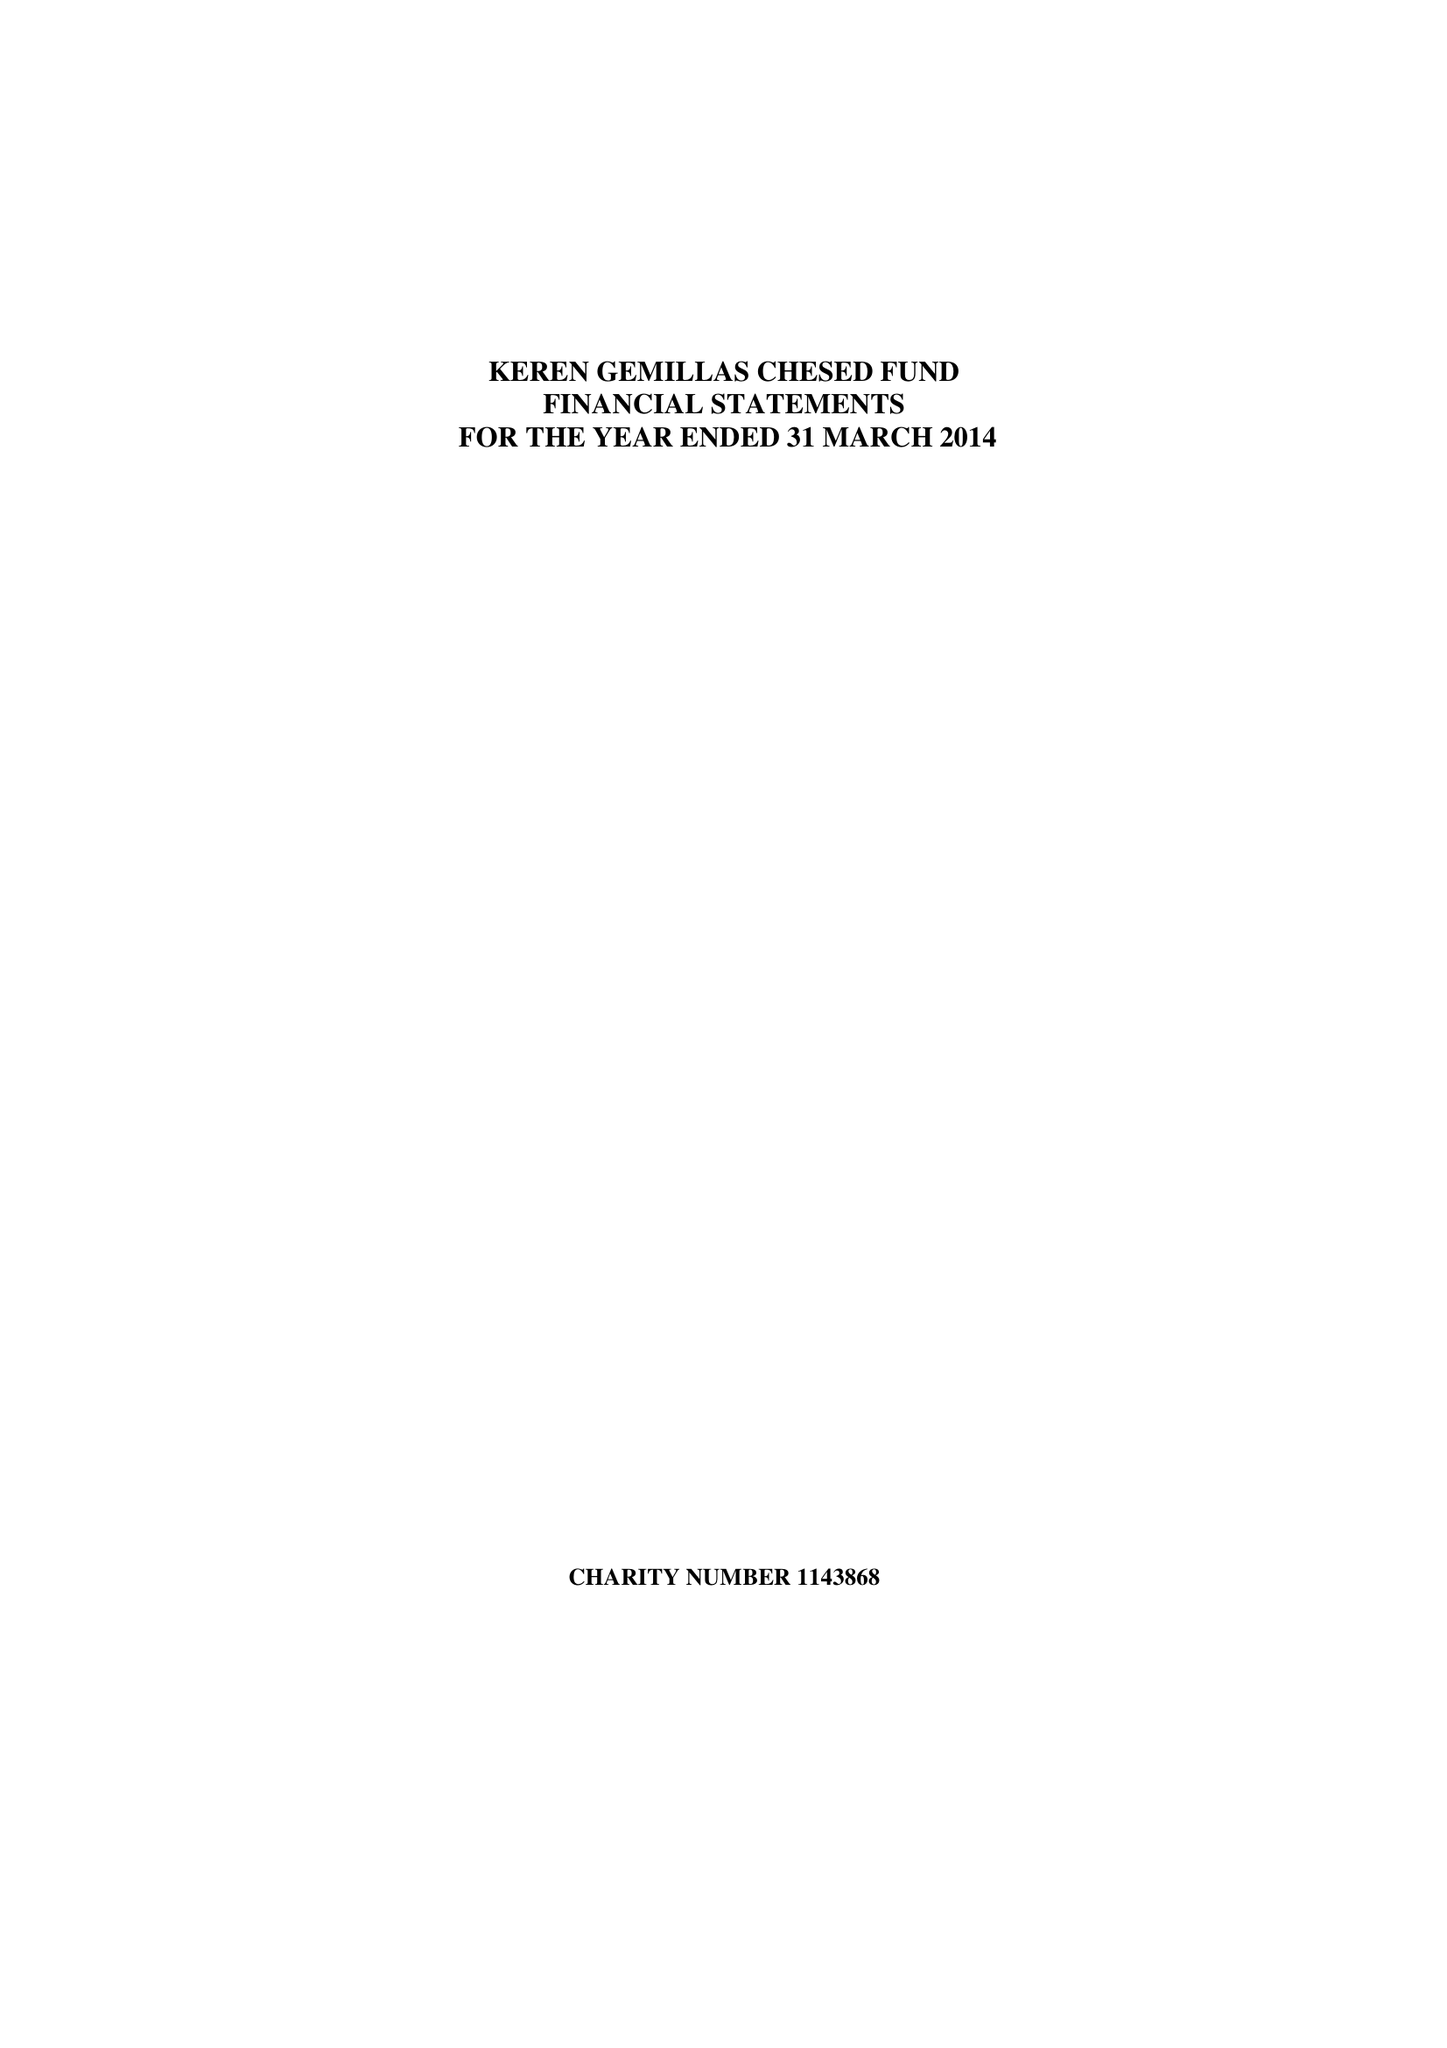What is the value for the spending_annually_in_british_pounds?
Answer the question using a single word or phrase. 55327.00 